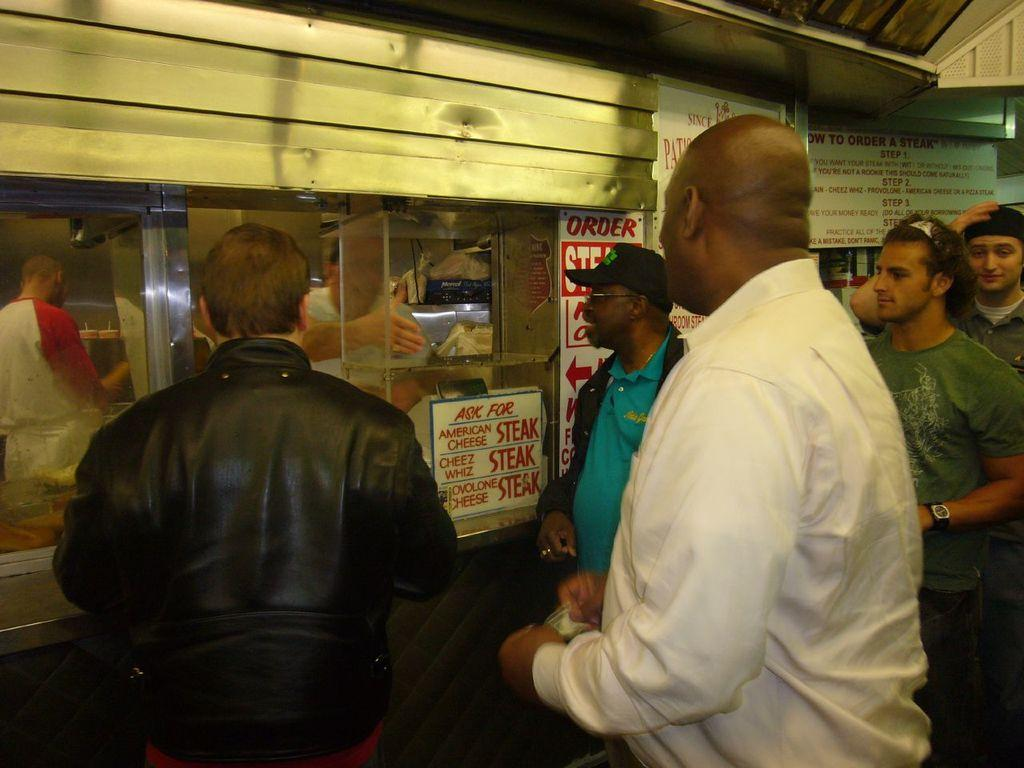What is the main subject in the foreground of the image? There is a crowd in the foreground of the image. What are the people in the crowd standing in front of? The crowd is standing in front of a food truck. What type of objects can be seen in the image besides the crowd and food truck? There are boards visible in the image. What time of day is the image taken? The image is taken during night. Where is the scene located? The scene is on a street. What type of writing can be seen on the boards in the image? There is no writing visible on the boards in the image. How many ants are crawling on the food truck in the image? There are no ants present in the image; it features a crowd standing in front of a food truck. 